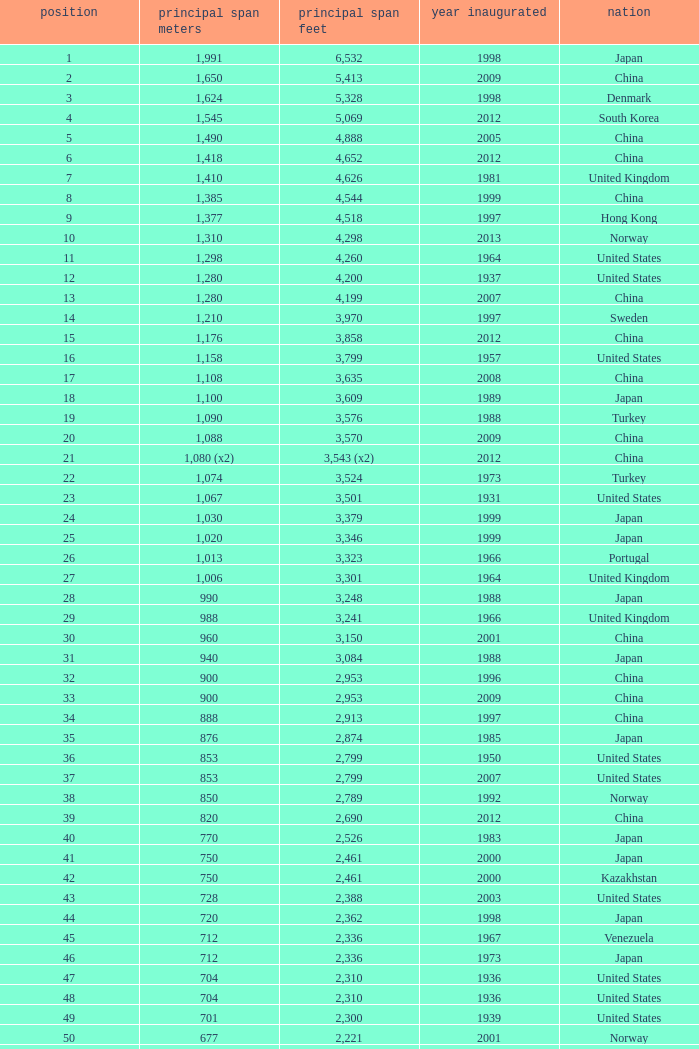What is the oldest year with a main span feet of 1,640 in South Korea? 2002.0. Parse the table in full. {'header': ['position', 'principal span meters', 'principal span feet', 'year inaugurated', 'nation'], 'rows': [['1', '1,991', '6,532', '1998', 'Japan'], ['2', '1,650', '5,413', '2009', 'China'], ['3', '1,624', '5,328', '1998', 'Denmark'], ['4', '1,545', '5,069', '2012', 'South Korea'], ['5', '1,490', '4,888', '2005', 'China'], ['6', '1,418', '4,652', '2012', 'China'], ['7', '1,410', '4,626', '1981', 'United Kingdom'], ['8', '1,385', '4,544', '1999', 'China'], ['9', '1,377', '4,518', '1997', 'Hong Kong'], ['10', '1,310', '4,298', '2013', 'Norway'], ['11', '1,298', '4,260', '1964', 'United States'], ['12', '1,280', '4,200', '1937', 'United States'], ['13', '1,280', '4,199', '2007', 'China'], ['14', '1,210', '3,970', '1997', 'Sweden'], ['15', '1,176', '3,858', '2012', 'China'], ['16', '1,158', '3,799', '1957', 'United States'], ['17', '1,108', '3,635', '2008', 'China'], ['18', '1,100', '3,609', '1989', 'Japan'], ['19', '1,090', '3,576', '1988', 'Turkey'], ['20', '1,088', '3,570', '2009', 'China'], ['21', '1,080 (x2)', '3,543 (x2)', '2012', 'China'], ['22', '1,074', '3,524', '1973', 'Turkey'], ['23', '1,067', '3,501', '1931', 'United States'], ['24', '1,030', '3,379', '1999', 'Japan'], ['25', '1,020', '3,346', '1999', 'Japan'], ['26', '1,013', '3,323', '1966', 'Portugal'], ['27', '1,006', '3,301', '1964', 'United Kingdom'], ['28', '990', '3,248', '1988', 'Japan'], ['29', '988', '3,241', '1966', 'United Kingdom'], ['30', '960', '3,150', '2001', 'China'], ['31', '940', '3,084', '1988', 'Japan'], ['32', '900', '2,953', '1996', 'China'], ['33', '900', '2,953', '2009', 'China'], ['34', '888', '2,913', '1997', 'China'], ['35', '876', '2,874', '1985', 'Japan'], ['36', '853', '2,799', '1950', 'United States'], ['37', '853', '2,799', '2007', 'United States'], ['38', '850', '2,789', '1992', 'Norway'], ['39', '820', '2,690', '2012', 'China'], ['40', '770', '2,526', '1983', 'Japan'], ['41', '750', '2,461', '2000', 'Japan'], ['42', '750', '2,461', '2000', 'Kazakhstan'], ['43', '728', '2,388', '2003', 'United States'], ['44', '720', '2,362', '1998', 'Japan'], ['45', '712', '2,336', '1967', 'Venezuela'], ['46', '712', '2,336', '1973', 'Japan'], ['47', '704', '2,310', '1936', 'United States'], ['48', '704', '2,310', '1936', 'United States'], ['49', '701', '2,300', '1939', 'United States'], ['50', '677', '2,221', '2001', 'Norway'], ['51', '668', '2,192', '1969', 'Canada'], ['52', '656', '2,152', '1968', 'United States'], ['53', '656', '2152', '1951', 'United States'], ['54', '648', '2,126', '1999', 'China'], ['55', '636', '2,087', '2009', 'China'], ['56', '623', '2,044', '1992', 'Norway'], ['57', '616', '2,021', '2009', 'China'], ['58', '610', '2,001', '1957', 'United States'], ['59', '608', '1,995', '1959', 'France'], ['60', '600', '1,969', '1970', 'Denmark'], ['61', '600', '1,969', '1999', 'Japan'], ['62', '600', '1,969', '2000', 'China'], ['63', '595', '1,952', '1997', 'Norway'], ['64', '580', '1,903', '2003', 'China'], ['65', '577', '1,893', '2001', 'Norway'], ['66', '570', '1,870', '1993', 'Japan'], ['67', '564', '1,850', '1929', 'United States Canada'], ['68', '560', '1,837', '1988', 'Japan'], ['69', '560', '1,837', '2001', 'China'], ['70', '549', '1,801', '1961', 'United States'], ['71', '540', '1,772', '2008', 'Japan'], ['72', '534', '1,752', '1926', 'United States'], ['73', '525', '1,722', '1972', 'Norway'], ['74', '525', '1,722', '1977', 'Norway'], ['75', '520', '1,706', '1983', 'Democratic Republic of the Congo'], ['76', '500', '1,640', '1965', 'Germany'], ['77', '500', '1,640', '2002', 'South Korea'], ['78', '497', '1,631', '1924', 'United States'], ['79', '488', '1,601', '1903', 'United States'], ['80', '488', '1,601', '1969', 'United States'], ['81', '488', '1,601', '1952', 'United States'], ['82', '488', '1,601', '1973', 'United States'], ['83', '486', '1,594', '1883', 'United States'], ['84', '473', '1,552', '1938', 'Canada'], ['85', '468', '1,535', '1971', 'Norway'], ['86', '465', '1,526', '1977', 'Japan'], ['87', '457', '1,499', '1930', 'United States'], ['88', '457', '1,499', '1963', 'United States'], ['89', '452', '1,483', '1995', 'China'], ['90', '450', '1,476', '1997', 'China'], ['91', '448', '1,470', '1909', 'United States'], ['92', '446', '1,463', '1997', 'Norway'], ['93', '441', '1,447', '1955', 'Canada'], ['94', '430', '1,411', '2012', 'China'], ['95', '427', '1,401', '1970', 'Canada'], ['96', '421', '1,381', '1936', 'United States'], ['97', '417', '1,368', '1966', 'Sweden'], ['98', '408', '1339', '2010', 'China'], ['99', '405', '1,329', '2009', 'Vietnam'], ['100', '404', '1,325', '1973', 'South Korea'], ['101', '394', '1,293', '1967', 'France'], ['102', '390', '1,280', '1964', 'Uzbekistan'], ['103', '385', '1,263', '2013', 'United States'], ['104', '378', '1,240', '1954', 'Germany'], ['105', '368', '1,207', '1931', 'United States'], ['106', '367', '1,204', '1962', 'Japan'], ['107', '366', '1,200', '1929', 'United States'], ['108', '351', '1,151', '1960', 'United States Canada'], ['109', '350', '1,148', '2006', 'China'], ['110', '340', '1,115', '1926', 'Brazil'], ['111', '338', '1,109', '2001', 'China'], ['112', '338', '1,108', '1965', 'United States'], ['113', '337', '1,106', '1956', 'Norway'], ['114', '335', '1,100', '1961', 'United Kingdom'], ['115', '335', '1,100', '2006', 'Norway'], ['116', '329', '1,088', '1939', 'United States'], ['117', '328', '1,085', '1939', 'Zambia Zimbabwe'], ['118', '325', '1,066', '1964', 'Norway'], ['119', '325', '1,066', '1981', 'Norway'], ['120', '323', '1,060', '1932', 'United States'], ['121', '323', '1,059', '1936', 'Canada'], ['122', '322', '1,057', '1867', 'United States'], ['123', '320', '1,050', '1971', 'United States'], ['124', '320', '1,050', '2011', 'Peru'], ['125', '315', '1,033', '1951', 'Germany'], ['126', '308', '1,010', '1849', 'United States'], ['127', '300', '985', '1961', 'Canada'], ['128', '300', '984', '1987', 'Japan'], ['129', '300', '984', '2000', 'France'], ['130', '300', '984', '2000', 'South Korea']]} 